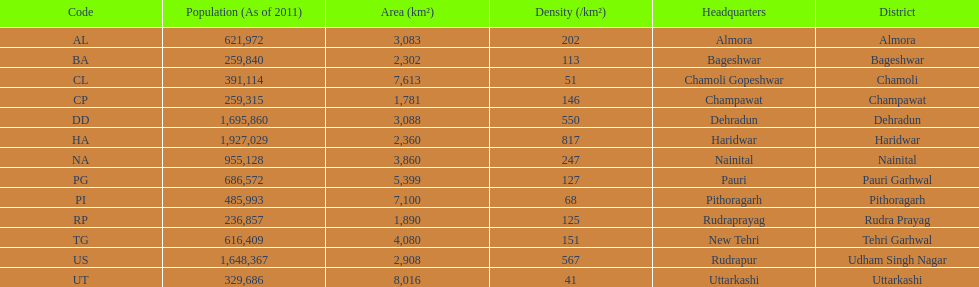How many total districts are there in this area? 13. 